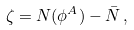Convert formula to latex. <formula><loc_0><loc_0><loc_500><loc_500>\zeta = N ( \phi ^ { A } ) - \bar { N } \, ,</formula> 